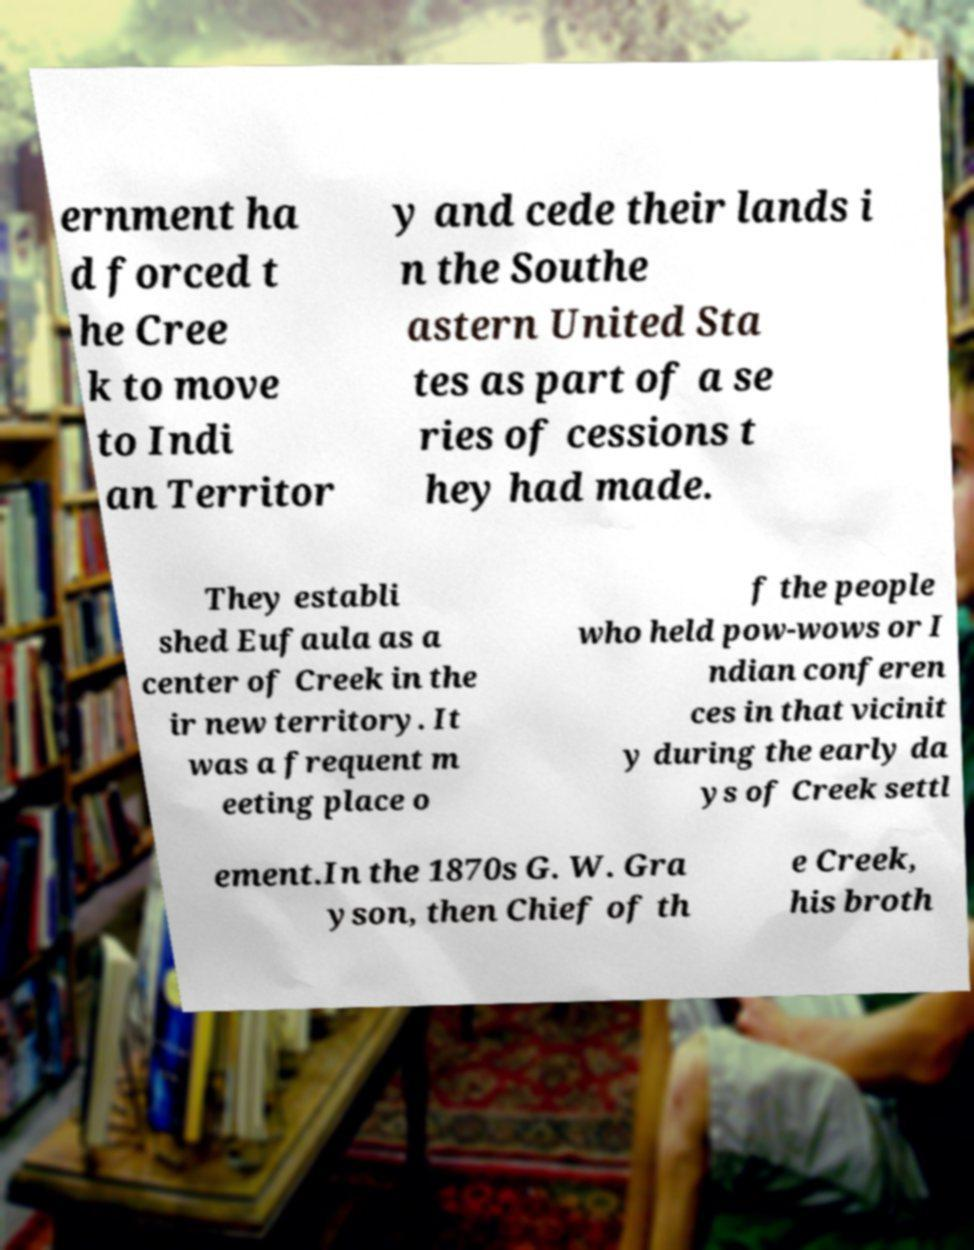There's text embedded in this image that I need extracted. Can you transcribe it verbatim? ernment ha d forced t he Cree k to move to Indi an Territor y and cede their lands i n the Southe astern United Sta tes as part of a se ries of cessions t hey had made. They establi shed Eufaula as a center of Creek in the ir new territory. It was a frequent m eeting place o f the people who held pow-wows or I ndian conferen ces in that vicinit y during the early da ys of Creek settl ement.In the 1870s G. W. Gra yson, then Chief of th e Creek, his broth 